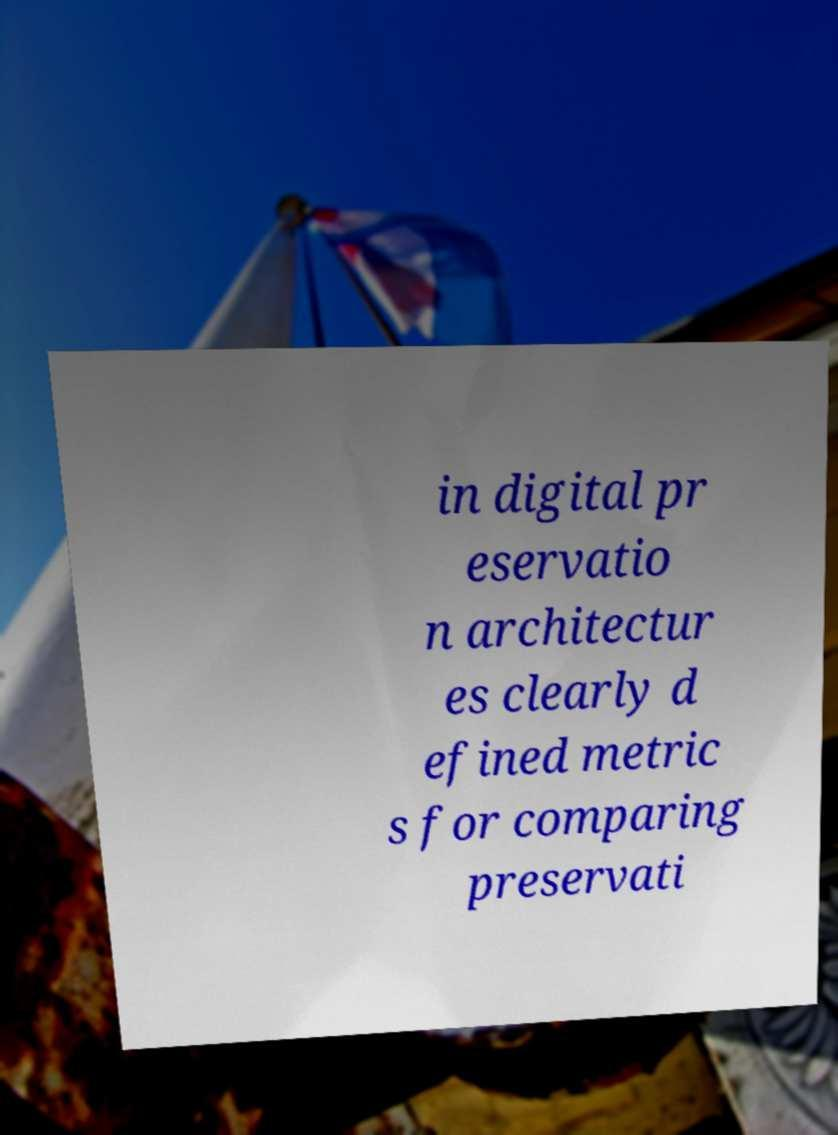I need the written content from this picture converted into text. Can you do that? in digital pr eservatio n architectur es clearly d efined metric s for comparing preservati 